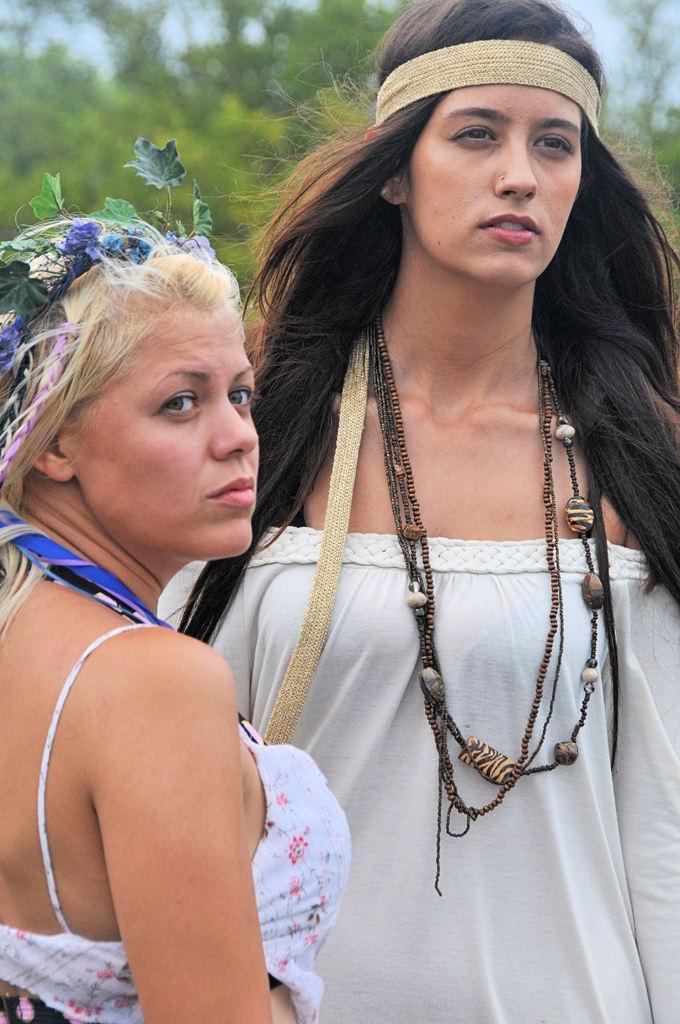Could you give a brief overview of what you see in this image? In this image there are two persons standing, and in the background there are trees and sky. 